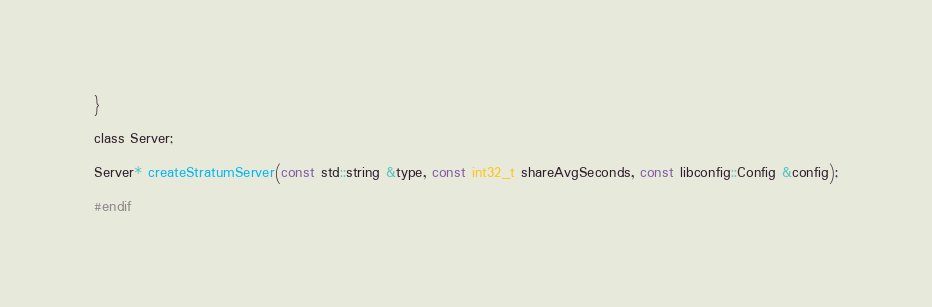Convert code to text. <code><loc_0><loc_0><loc_500><loc_500><_C_>}

class Server;

Server* createStratumServer(const std::string &type, const int32_t shareAvgSeconds, const libconfig::Config &config);

#endif</code> 